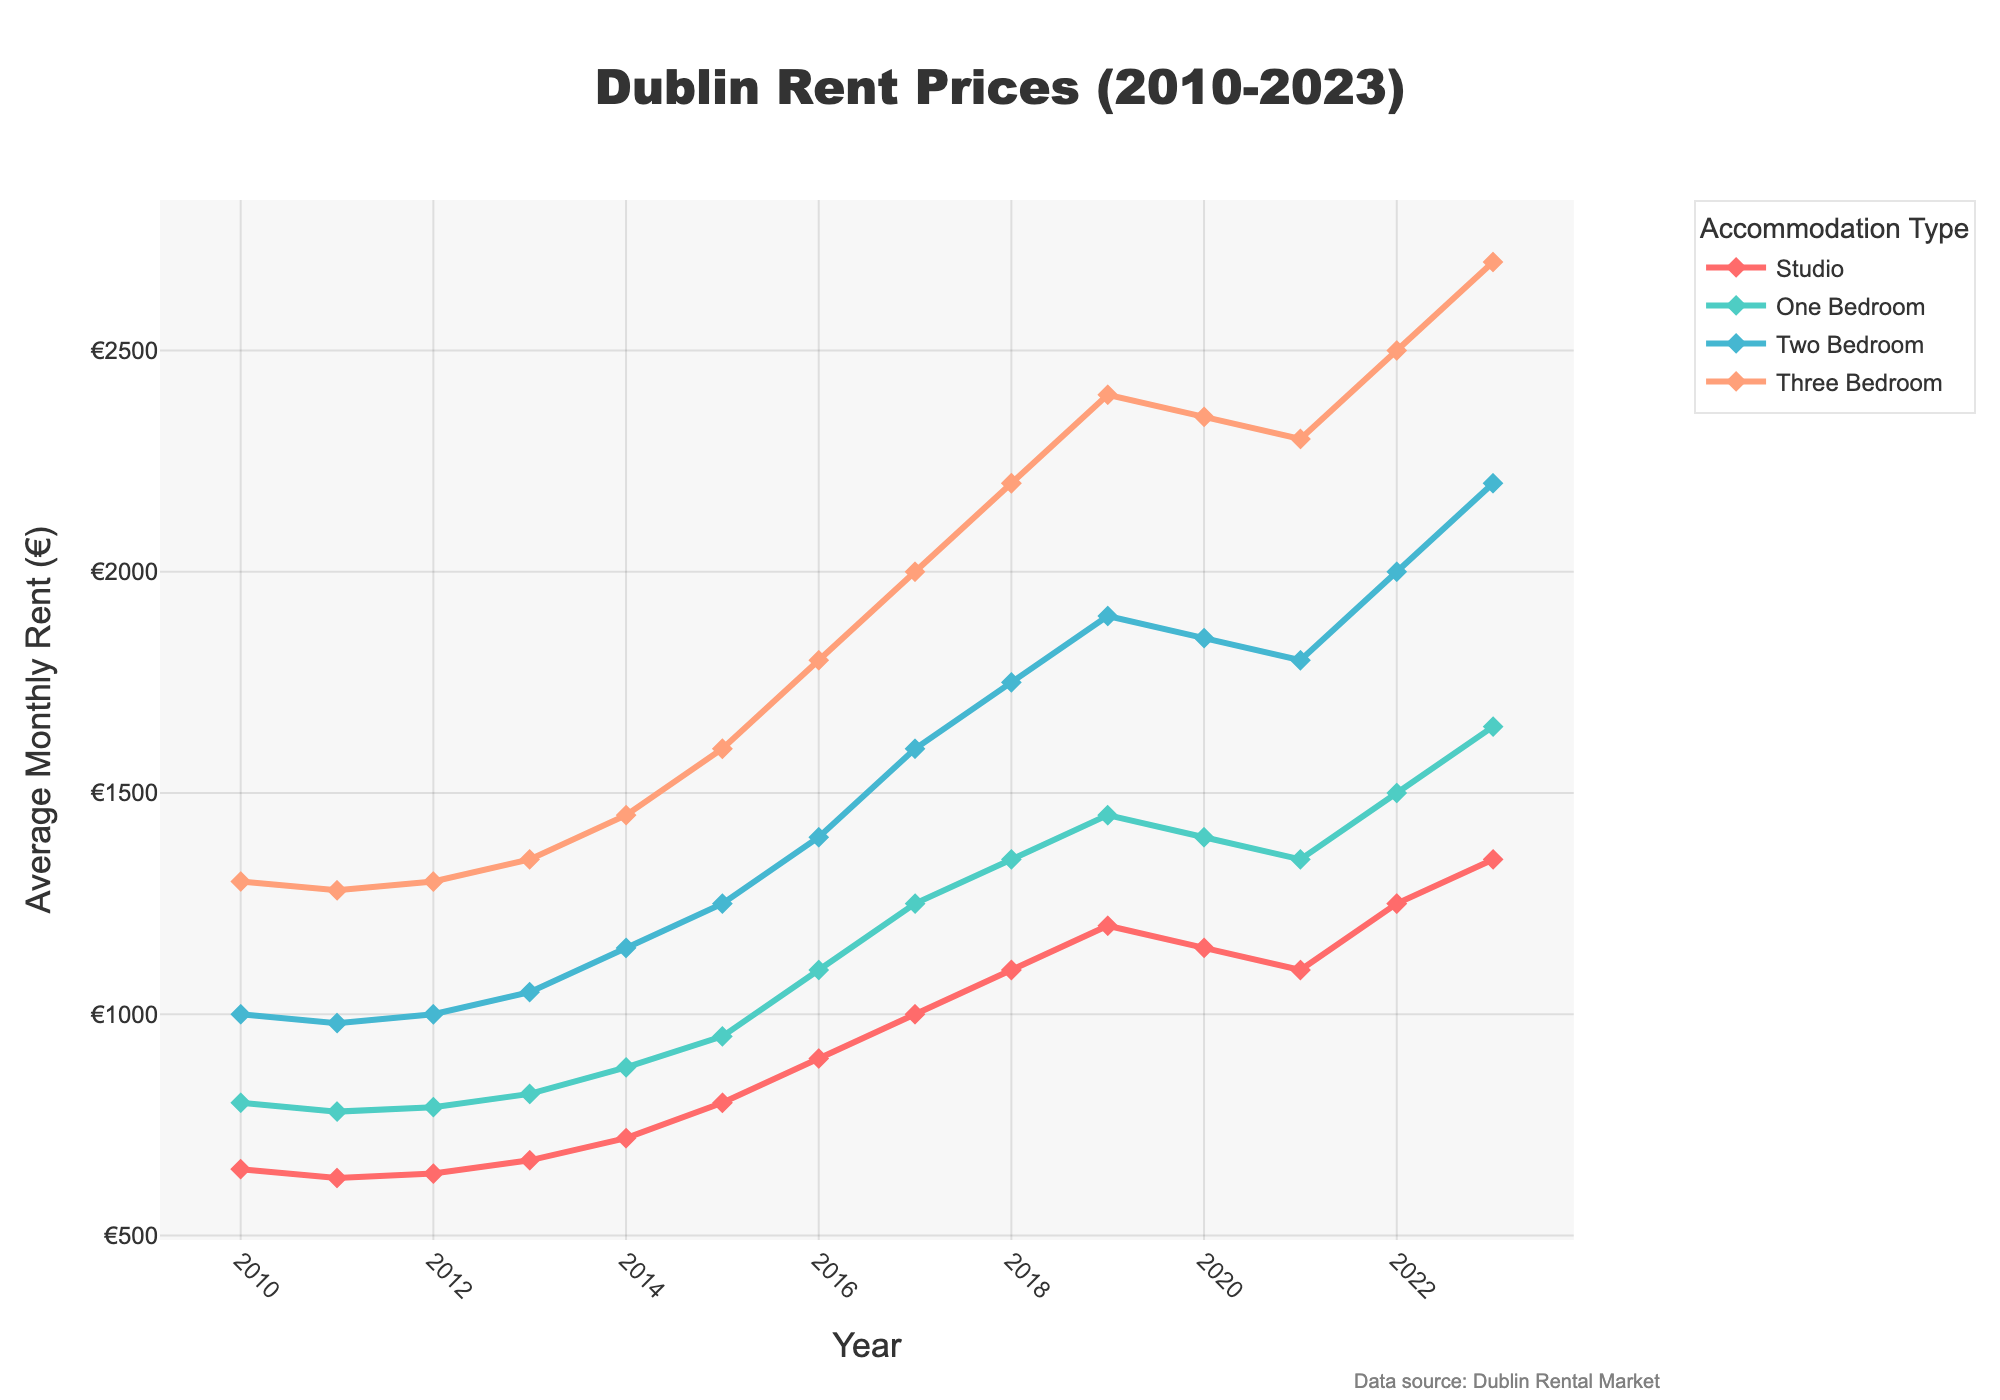What year had the highest average monthly rent for a studio apartment? Look for the highest point on the line representing studio apartments. The peak is at 2023.
Answer: 2023 Which type of accommodation saw the biggest increase in rent prices from 2010 to 2023? Calculate the difference from 2023 to 2010 for each type: Studio (1350 - 650 = 700), One Bedroom (1650 - 800 = 850), Two Bedroom (2200 - 1000 = 1200), Three Bedroom (2700 - 1300 = 1400). The largest increase is for Three Bedroom.
Answer: Three Bedroom Did the average rent for one-bedroom apartments ever decrease between any two consecutive years? Check the line for One Bedroom apartments to see if it goes down at any point. From 2010 to 2021, it only decreased once between 2019 and 2020.
Answer: Yes Between what years did the two-bedroom apartment rent prices increase the fastest? Identify the steepest slope on the line for Two Bedroom apartments. The steepest increase appears between 2014 (1150) and 2016 (1400), which is 250 in 2 years.
Answer: 2014-2016 Which year had the smallest rent price difference between studio and one-bedroom apartments? Calculate the difference for each year: 2010 (150), 2011 (150), 2012 (150), 2013 (150), 2014 (160), 2015 (150), 2016 (200), 2017 (250), 2018 (250), 2019 (250), 2020 (250), 2021 (250), 2022 (250), 2023 (300). The smallest difference is 2010-2013 (150).
Answer: 2010-2013 How much more expensive was a three-bedroom apartment compared to a one-bedroom apartment in 2023? Subtract the rent of one-bedroom from that of three-bedroom in 2023: 2700 - 1650 = 1050.
Answer: 1050 By how much did rent prices for studio apartments fluctuate from 2010 to 2023? Identify the minimum and maximum rents for studio apartments: 2011 (minimum, 630), 2023 (maximum, 1350). The fluctuation is 1350 - 630 = 720.
Answer: 720 Which accommodation type had the least volatile rent changes over the years? Compare the smoothness (least ups and downs) of each line. The line for Studio apartments appears the least volatile with gradual changes.
Answer: Studio In what year did the rent prices for two-bedroom apartments hit €2000? Check where the Two Bedroom line intersects the €2000 mark. It first hits €2000 in 2022.
Answer: 2022 